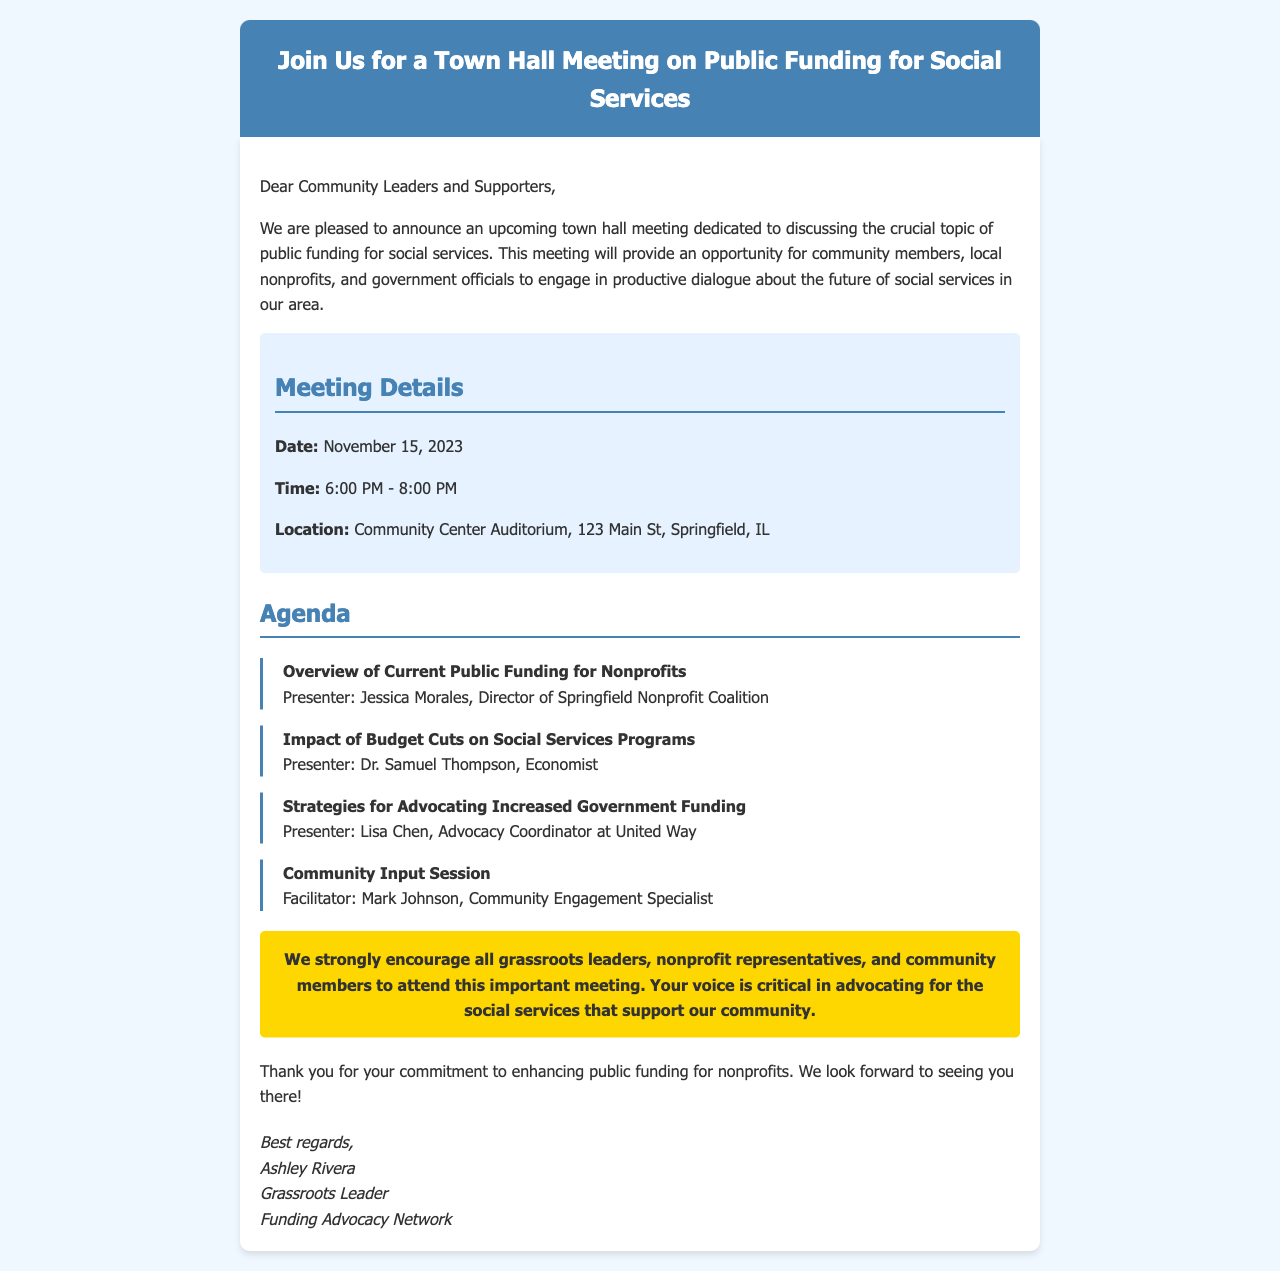What is the date of the town hall meeting? The date of the meeting is specified in the meeting details section of the document.
Answer: November 15, 2023 What time will the town hall meeting start? The start time is listed in the meeting details and refers to when the meeting begins.
Answer: 6:00 PM Who is facilitating the Community Input Session? The document names the facilitator in the agenda section specifically for the Community Input Session.
Answer: Mark Johnson What is the location of the meeting? The location is clearly stated in the meeting details for attendees to know where to go.
Answer: Community Center Auditorium, 123 Main St, Springfield, IL Who will present the topic on Strategies for Advocating Increased Government Funding? The presenter for this specific agenda item is mentioned right after the session title in the agenda.
Answer: Lisa Chen What color is the header background? The color details about the design are included in the style section of the document.
Answer: Blue How many agenda items are listed in total? The number of agenda items can be counted within the agenda section presented in the document.
Answer: Four What is the call to action encouraging attendees to do? The purpose of the call to action is emphasized within that section, addressing what the meeting aims to achieve with participants.
Answer: Attend this important meeting What organization is Ashley Rivera associated with? The organization affiliation is stated at the end of the document in the signature section.
Answer: Funding Advocacy Network 